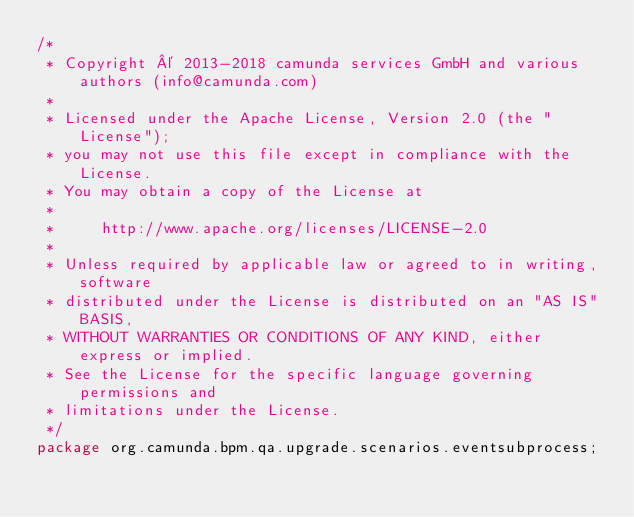<code> <loc_0><loc_0><loc_500><loc_500><_Java_>/*
 * Copyright © 2013-2018 camunda services GmbH and various authors (info@camunda.com)
 *
 * Licensed under the Apache License, Version 2.0 (the "License");
 * you may not use this file except in compliance with the License.
 * You may obtain a copy of the License at
 *
 *     http://www.apache.org/licenses/LICENSE-2.0
 *
 * Unless required by applicable law or agreed to in writing, software
 * distributed under the License is distributed on an "AS IS" BASIS,
 * WITHOUT WARRANTIES OR CONDITIONS OF ANY KIND, either express or implied.
 * See the License for the specific language governing permissions and
 * limitations under the License.
 */
package org.camunda.bpm.qa.upgrade.scenarios.eventsubprocess;
</code> 